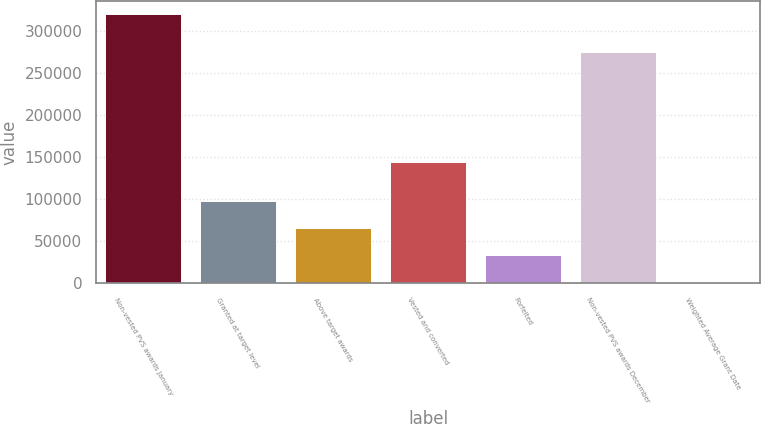Convert chart. <chart><loc_0><loc_0><loc_500><loc_500><bar_chart><fcel>Non-vested PVS awards January<fcel>Granted at target level<fcel>Above target awards<fcel>Vested and converted<fcel>Forfeited<fcel>Non-vested PVS awards December<fcel>Weighted Average Grant Date<nl><fcel>319899<fcel>97373.9<fcel>65584.6<fcel>144750<fcel>33795.3<fcel>275145<fcel>2006<nl></chart> 